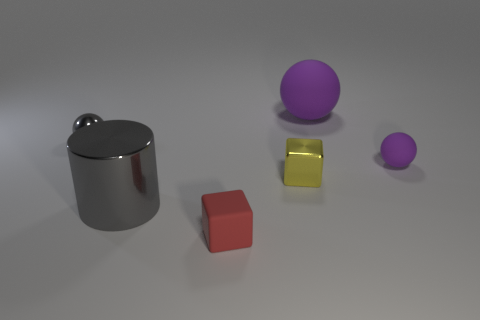How many yellow objects are tiny metal cubes or matte things?
Give a very brief answer. 1. The tiny metal object that is on the right side of the small metal object that is behind the tiny purple matte thing is what shape?
Your answer should be compact. Cube. What shape is the matte object that is the same size as the red cube?
Keep it short and to the point. Sphere. Are there any big metal cylinders that have the same color as the small rubber ball?
Give a very brief answer. No. Are there an equal number of tiny spheres that are on the right side of the metallic sphere and purple matte objects in front of the tiny purple object?
Make the answer very short. No. There is a tiny yellow metal object; does it have the same shape as the matte thing that is in front of the large metal object?
Your response must be concise. Yes. What number of other things are there of the same material as the big cylinder
Ensure brevity in your answer.  2. There is a tiny yellow metallic cube; are there any cylinders on the left side of it?
Ensure brevity in your answer.  Yes. Is the size of the shiny cube the same as the sphere left of the red rubber thing?
Make the answer very short. Yes. What is the color of the ball that is to the right of the purple thing that is behind the gray ball?
Your answer should be compact. Purple. 